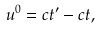<formula> <loc_0><loc_0><loc_500><loc_500>u ^ { 0 } = c t ^ { \prime } - c t ,</formula> 